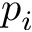Convert formula to latex. <formula><loc_0><loc_0><loc_500><loc_500>p _ { i }</formula> 